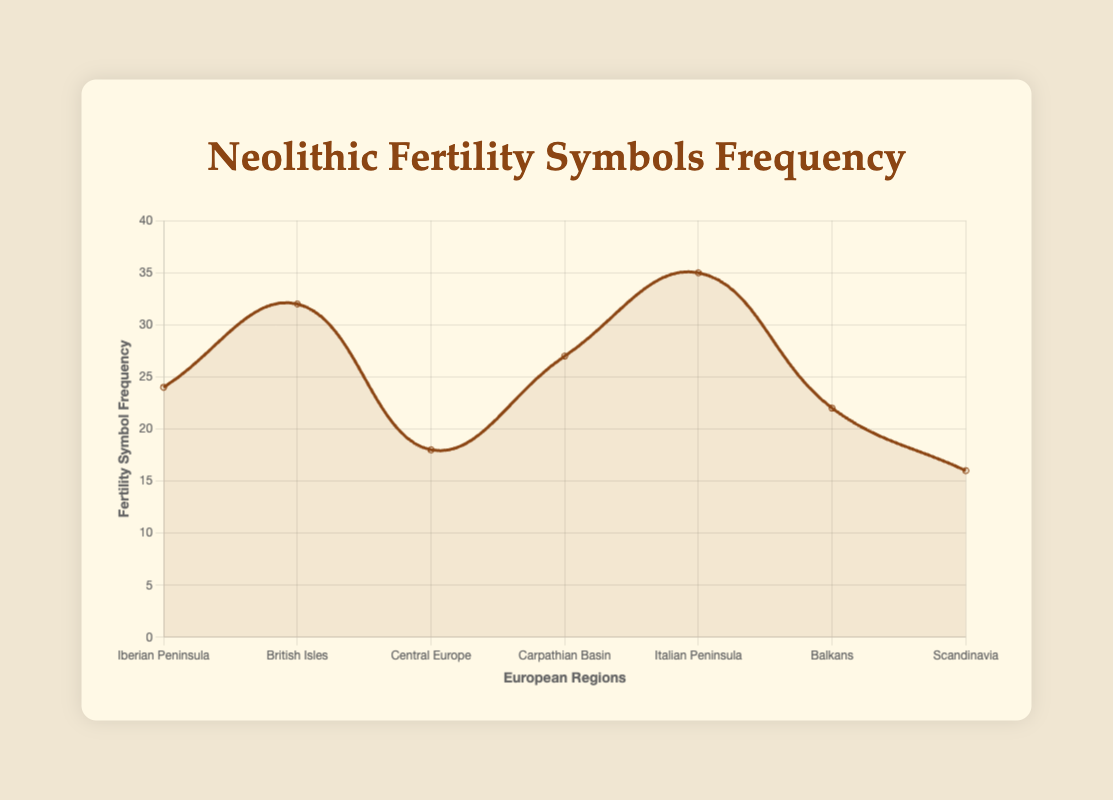What is the region with the highest frequency of fertility symbols? To find the region with the highest frequency of fertility symbols, we look for the highest point on the line plot. The Italian Peninsula has the highest point on the graph indicating 35 fertility symbols.
Answer: Italian Peninsula Which region has the lowest frequency of fertility symbols? To identify the region with the lowest frequency, we look for the lowest point on the line plot. Scandinavia has the lowest point on the graph with a frequency of 16 fertility symbols.
Answer: Scandinavia How many more fertility symbols are found in the British Isles compared to Central Europe? The British Isles have 32 fertility symbols, while Central Europe has 18. The difference is calculated as 32 - 18.
Answer: 14 Which two regions have the closest frequency of fertility symbols? By examining the graph, it is clear that the frequencies of the Balkans (22) and Iberian Peninsula (24) are close to each other, showing just a small difference.
Answer: Balkans and Iberian Peninsula What is the total frequency of fertility symbols in the Balkans and Carpathian Basin combined? The frequency in the Balkans is 22 and in the Carpathian Basin is 27. Adding these together: 22 + 27.
Answer: 49 By what percentage does the fertility symbol frequency in the Carpathian Basin exceed that of Scandinavia? The Carpathian Basin has 27 fertility symbols compared to Scandinavia's 16. The difference is 27 - 16 = 11. The percentage increase is calculated as (11/16) * 100.
Answer: 68.75% Which region is displayed with the second highest frequency of fertility symbols? After the Italian Peninsula, which has the highest, the British Isles have the next highest frequency with 32 fertility symbols.
Answer: British Isles Compare the fertility symbol frequency between the regions with the highest and lowest values. The region with the highest frequency is the Italian Peninsula (35) and the lowest is Scandinavia (16). The difference is 35 - 16.
Answer: 19 What is the average frequency of fertility symbols across all the regions? Summing the frequencies: 24 + 32 + 18 + 27 + 35 + 22 + 16 = 174. Dividing by the number of regions (7): 174 / 7.
Answer: 24.86 